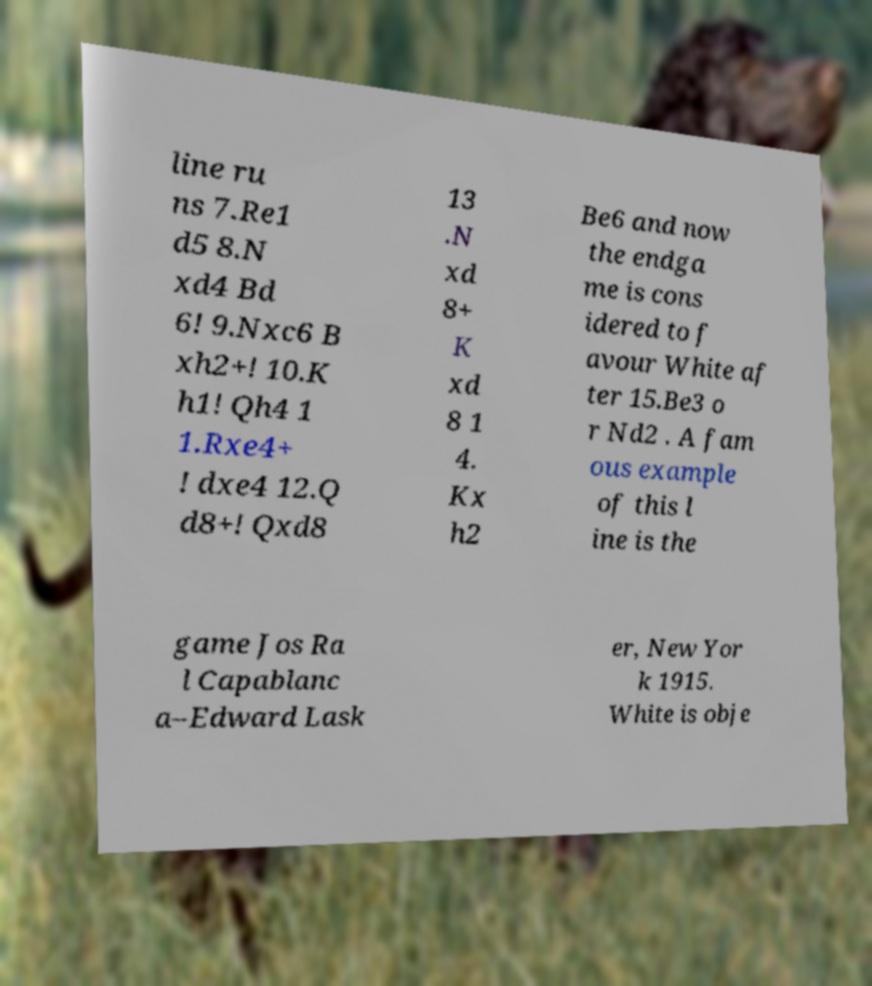Could you extract and type out the text from this image? line ru ns 7.Re1 d5 8.N xd4 Bd 6! 9.Nxc6 B xh2+! 10.K h1! Qh4 1 1.Rxe4+ ! dxe4 12.Q d8+! Qxd8 13 .N xd 8+ K xd 8 1 4. Kx h2 Be6 and now the endga me is cons idered to f avour White af ter 15.Be3 o r Nd2 . A fam ous example of this l ine is the game Jos Ra l Capablanc a–Edward Lask er, New Yor k 1915. White is obje 